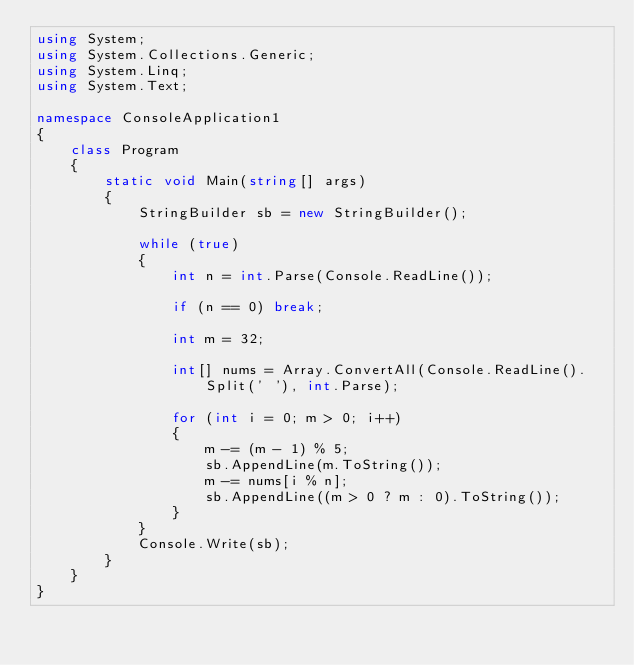<code> <loc_0><loc_0><loc_500><loc_500><_C#_>using System;
using System.Collections.Generic;
using System.Linq;
using System.Text;

namespace ConsoleApplication1
{
    class Program
    {
        static void Main(string[] args)
        {
            StringBuilder sb = new StringBuilder();

            while (true)
            {
                int n = int.Parse(Console.ReadLine());

                if (n == 0) break;

                int m = 32;

                int[] nums = Array.ConvertAll(Console.ReadLine().Split(' '), int.Parse);

                for (int i = 0; m > 0; i++)
                {
                    m -= (m - 1) % 5;
                    sb.AppendLine(m.ToString());
                    m -= nums[i % n];
                    sb.AppendLine((m > 0 ? m : 0).ToString());
                }
            }
            Console.Write(sb);
        }
    }
}</code> 